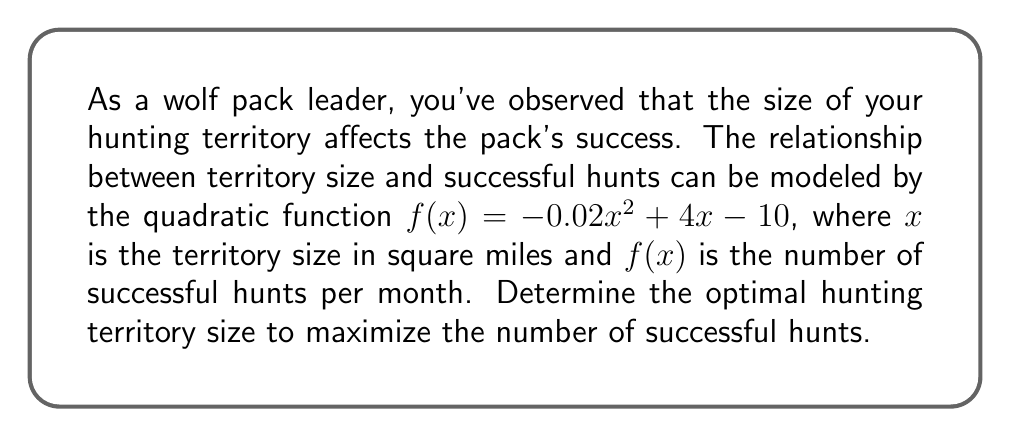Solve this math problem. To find the optimal hunting territory size, we need to find the maximum of the quadratic function. The steps are as follows:

1) The quadratic function is in the form $f(x) = ax^2 + bx + c$, where:
   $a = -0.02$, $b = 4$, and $c = -10$

2) For a quadratic function, the x-coordinate of the vertex represents the optimal value of x. We can find this using the formula: $x = -\frac{b}{2a}$

3) Substituting our values:
   $$x = -\frac{4}{2(-0.02)} = -\frac{4}{-0.04} = 100$$

4) To verify this is a maximum (not a minimum), we check that $a < 0$, which is true in this case.

5) Therefore, the optimal territory size is 100 square miles.

6) We can calculate the maximum number of successful hunts by substituting x = 100 into our original function:

   $$f(100) = -0.02(100)^2 + 4(100) - 10$$
   $$= -200 + 400 - 10$$
   $$= 190$$

Thus, at the optimal territory size, the pack can expect 190 successful hunts per month.
Answer: The optimal hunting territory size is 100 square miles, which results in a maximum of 190 successful hunts per month. 